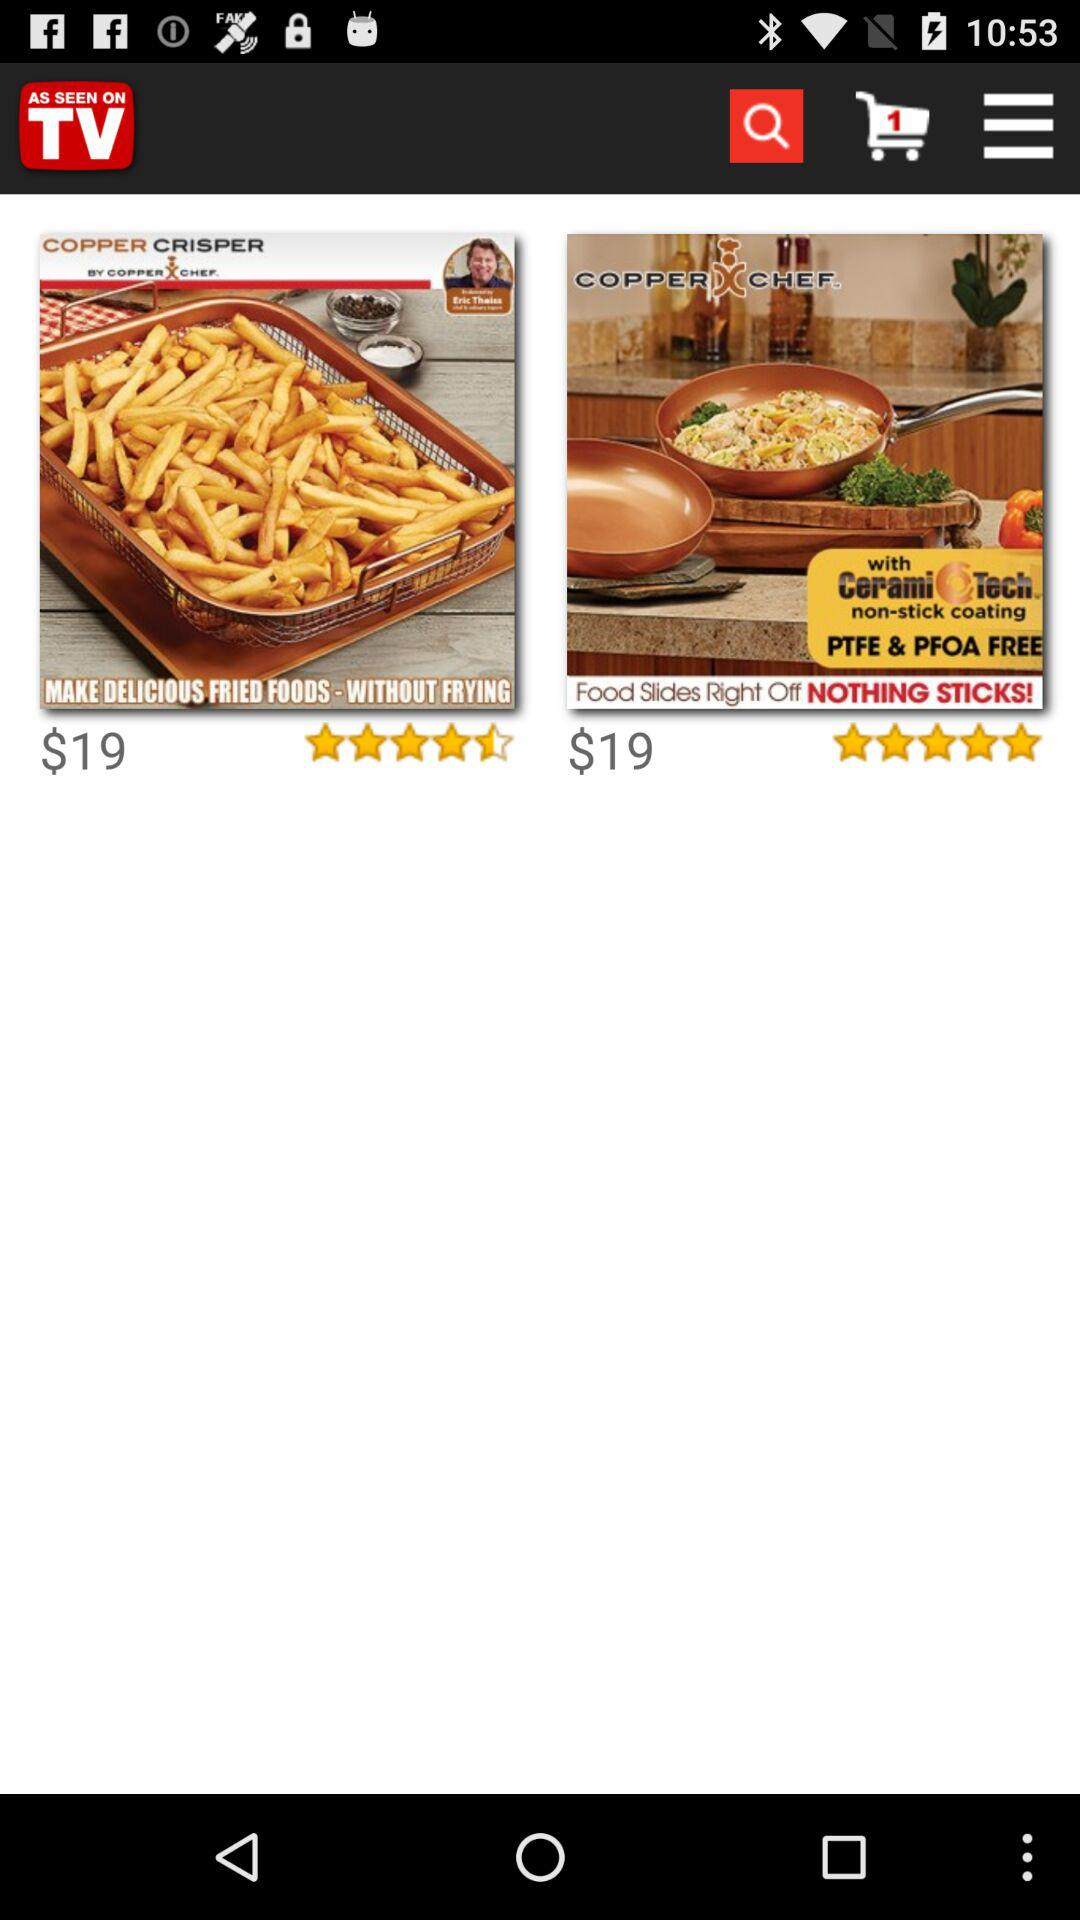What is the price? The price is $19. 